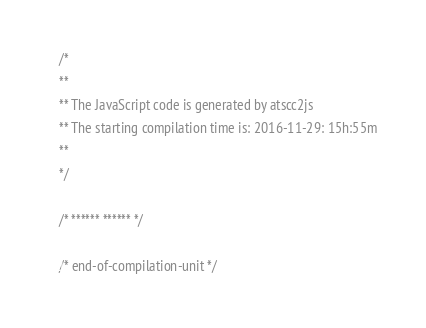<code> <loc_0><loc_0><loc_500><loc_500><_JavaScript_>/*
**
** The JavaScript code is generated by atscc2js
** The starting compilation time is: 2016-11-29: 15h:55m
**
*/

/* ****** ****** */

/* end-of-compilation-unit */
</code> 